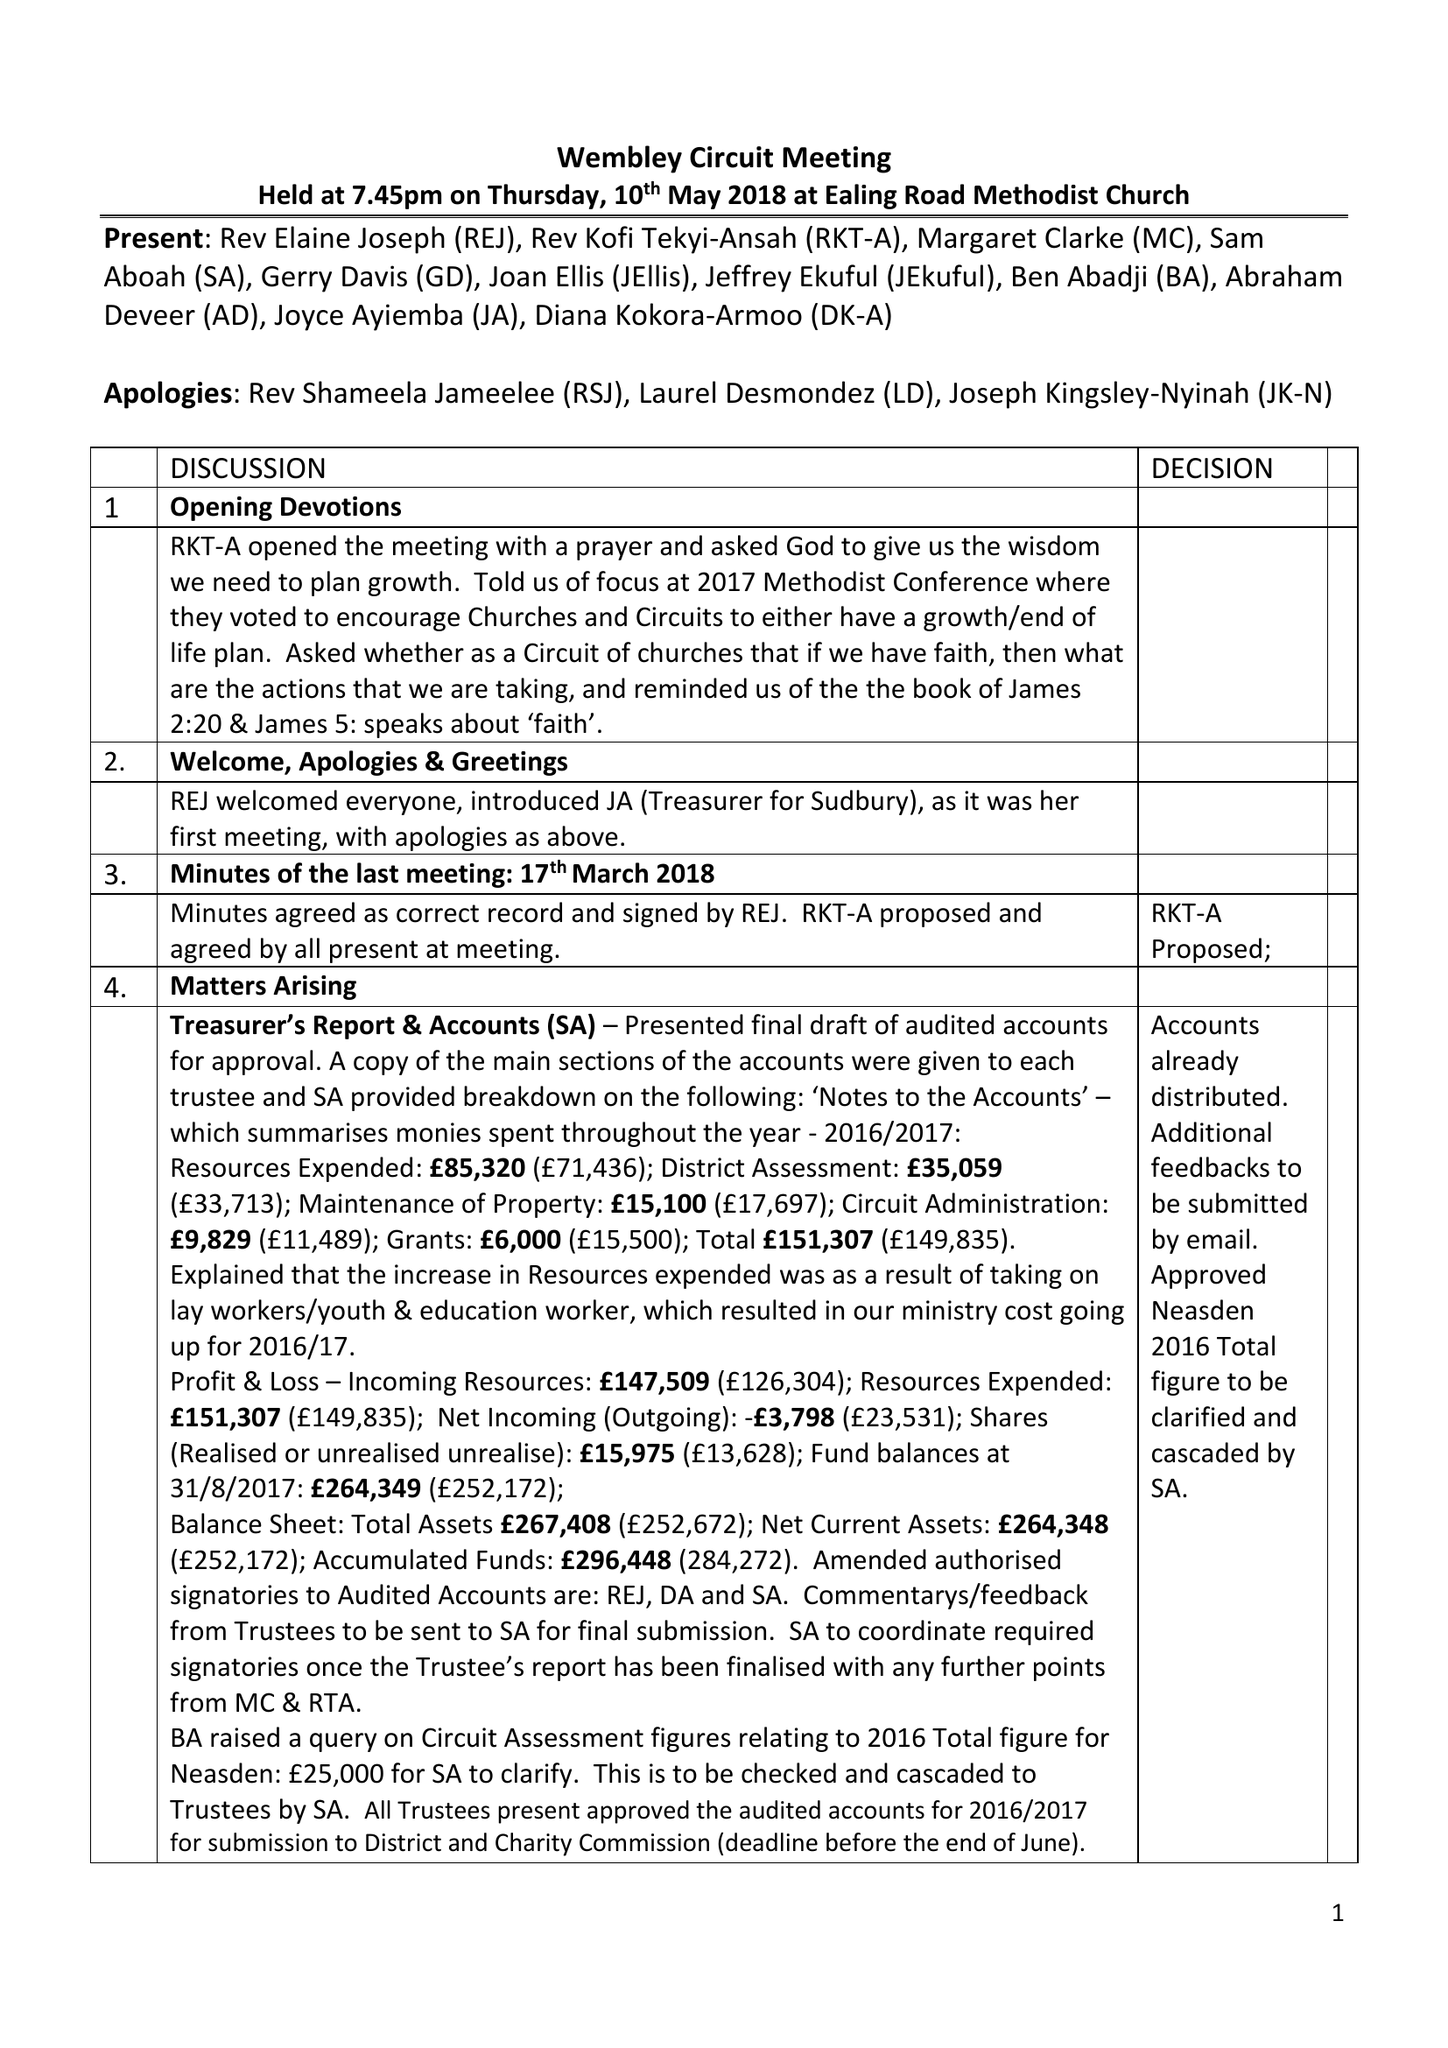What is the value for the charity_number?
Answer the question using a single word or phrase. 1169392 